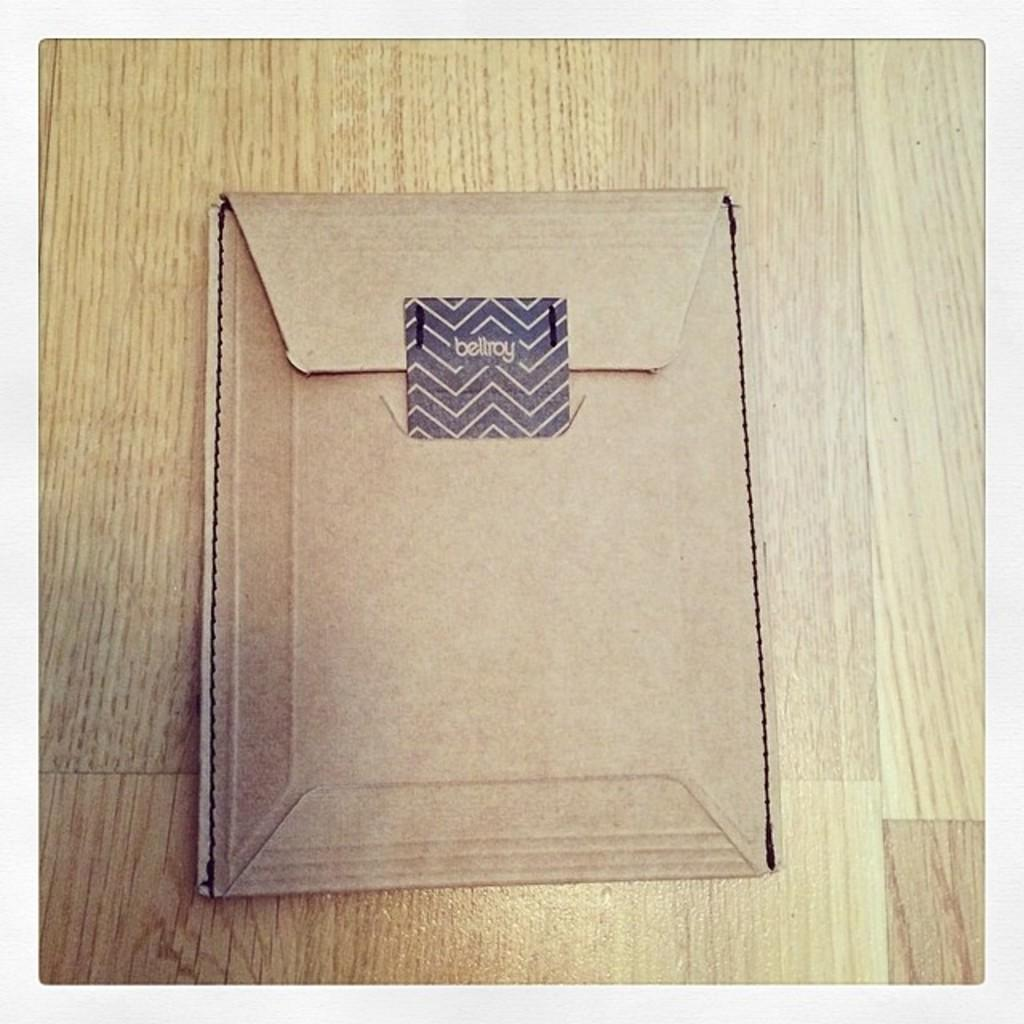<image>
Relay a brief, clear account of the picture shown. the word bellroy is on the brown item 